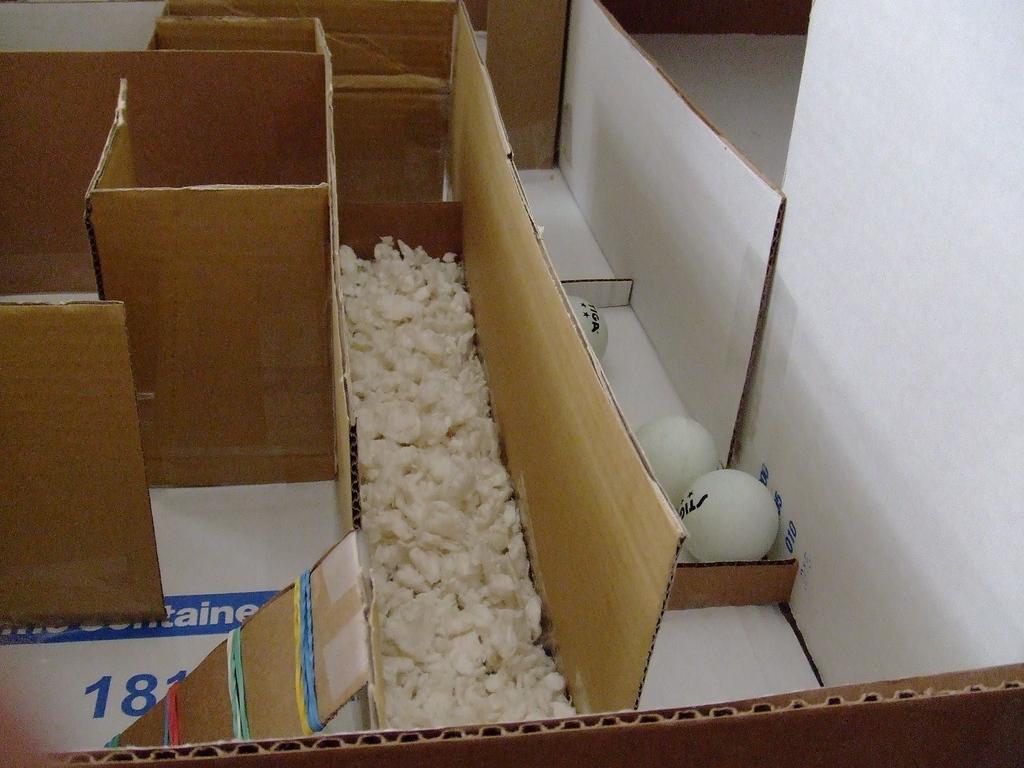What number is prominent in blue?
Make the answer very short. 181. What 3 letters are visible?
Offer a very short reply. Ain. 